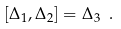<formula> <loc_0><loc_0><loc_500><loc_500>[ \Delta _ { 1 } , \Delta _ { 2 } ] = \Delta _ { 3 } \ .</formula> 